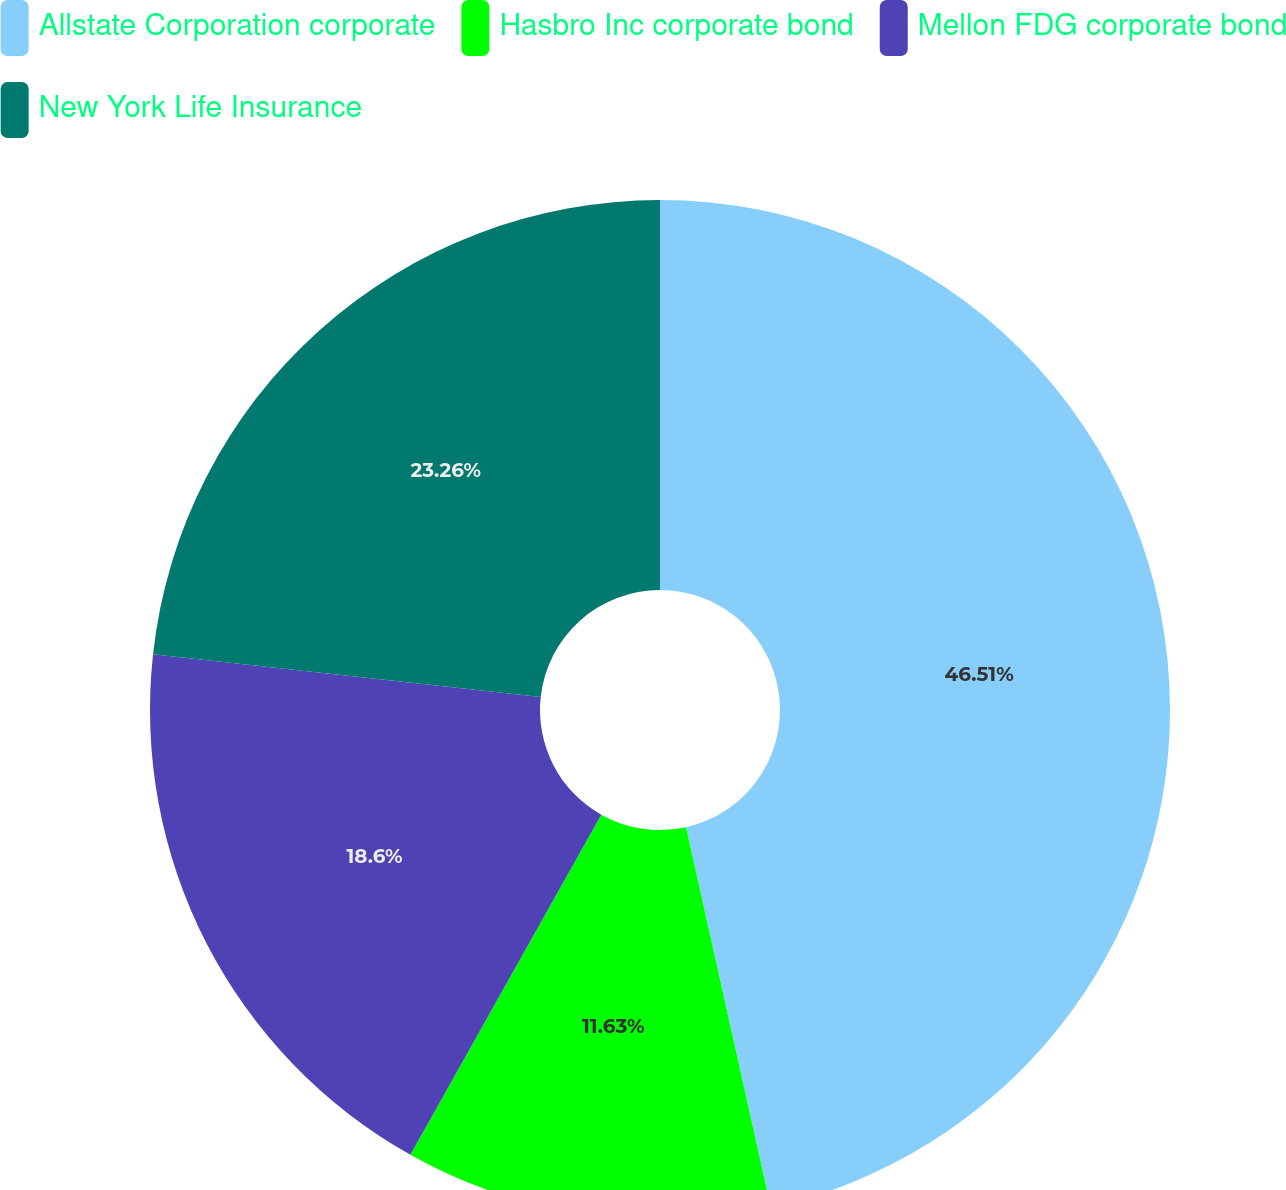<chart> <loc_0><loc_0><loc_500><loc_500><pie_chart><fcel>Allstate Corporation corporate<fcel>Hasbro Inc corporate bond<fcel>Mellon FDG corporate bond<fcel>New York Life Insurance<nl><fcel>46.51%<fcel>11.63%<fcel>18.6%<fcel>23.26%<nl></chart> 